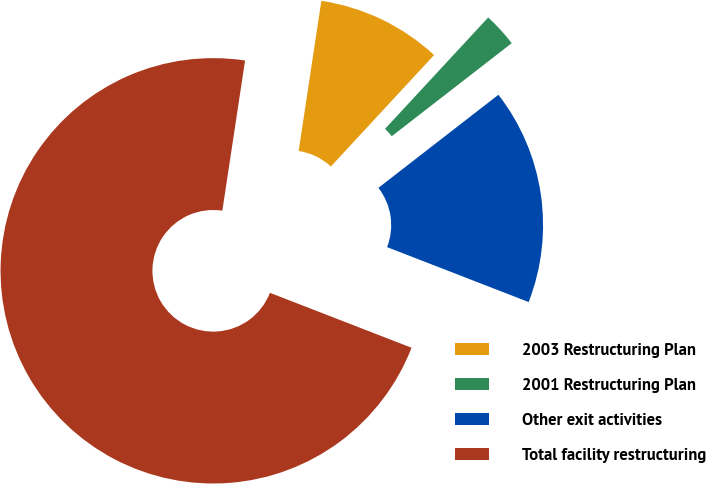Convert chart. <chart><loc_0><loc_0><loc_500><loc_500><pie_chart><fcel>2003 Restructuring Plan<fcel>2001 Restructuring Plan<fcel>Other exit activities<fcel>Total facility restructuring<nl><fcel>9.5%<fcel>2.61%<fcel>16.39%<fcel>71.5%<nl></chart> 